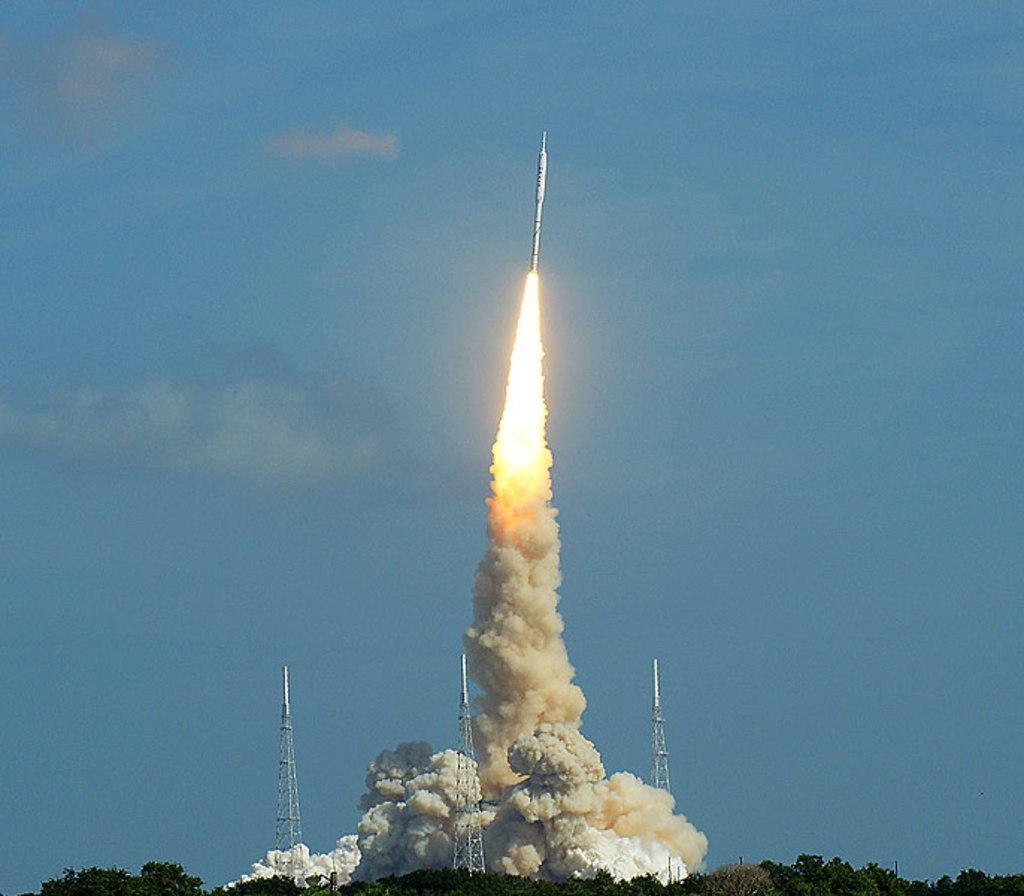How would you summarize this image in a sentence or two? In this image I can see the trees. I can see the towers. At the top I can see a rocket and clouds in the sky. 